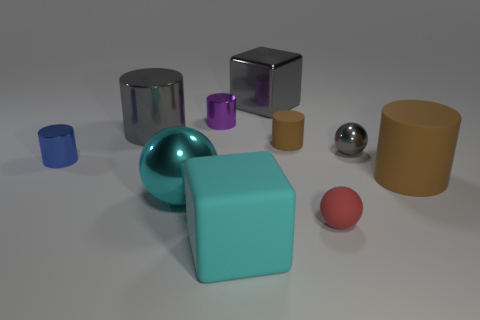What material is the big brown thing that is the same shape as the purple metallic thing?
Keep it short and to the point. Rubber. What material is the brown object that is the same size as the blue thing?
Ensure brevity in your answer.  Rubber. What number of tiny things are rubber cylinders or cyan balls?
Offer a terse response. 1. Is the number of large cyan balls on the left side of the metal cube the same as the number of tiny metal cylinders behind the large gray cylinder?
Your answer should be very brief. Yes. How many other objects are there of the same color as the tiny metal sphere?
Your answer should be very brief. 2. Are there an equal number of small red balls that are right of the gray metal sphere and tiny blue metallic cylinders?
Make the answer very short. No. Do the red rubber ball and the cyan matte thing have the same size?
Keep it short and to the point. No. What is the thing that is to the right of the tiny matte sphere and in front of the small gray sphere made of?
Provide a succinct answer. Rubber. How many small blue metal things are the same shape as the large brown thing?
Provide a succinct answer. 1. There is a ball that is behind the cyan shiny object; what is it made of?
Keep it short and to the point. Metal. 